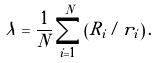Convert formula to latex. <formula><loc_0><loc_0><loc_500><loc_500>\lambda = \frac { 1 } { N } \sum _ { i = 1 } ^ { N } \left ( R _ { i } / r _ { i } \right ) .</formula> 